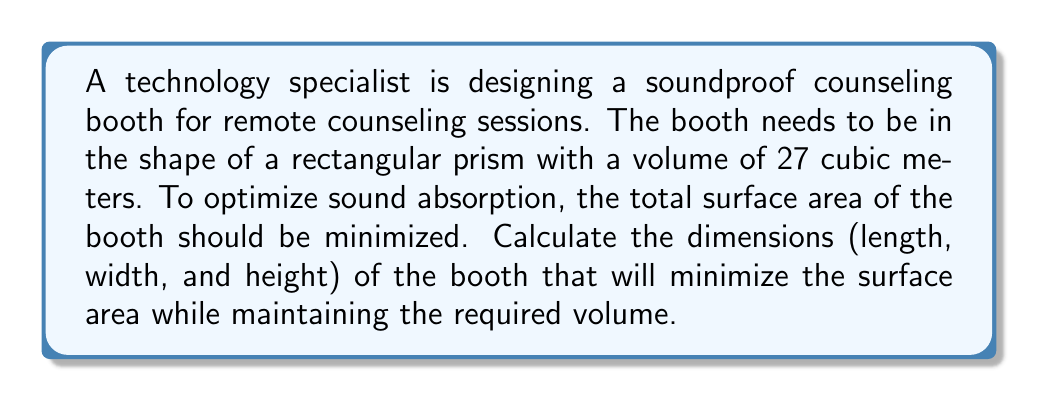Solve this math problem. Let's approach this step-by-step:

1) Let the dimensions of the booth be length $l$, width $w$, and height $h$.

2) Given: Volume = 27 cubic meters
   $$l \cdot w \cdot h = 27$$

3) Surface area of a rectangular prism is given by:
   $$SA = 2(lw + lh + wh)$$

4) We need to minimize SA subject to the constraint $lwh = 27$.

5) Using the method of Lagrange multipliers, we can show that the surface area is minimized when all dimensions are equal. This means:
   $$l = w = h$$

6) Substituting this into the volume equation:
   $$l^3 = 27$$

7) Solving for $l$:
   $$l = \sqrt[3]{27} = 3$$

8) Therefore, all dimensions (length, width, and height) should be 3 meters.

9) We can verify:
   Volume: $3 \cdot 3 \cdot 3 = 27$ cubic meters
   Surface Area: $2(3 \cdot 3 + 3 \cdot 3 + 3 \cdot 3) = 54$ square meters

This configuration provides the minimum surface area for the given volume.
Answer: 3 m × 3 m × 3 m 